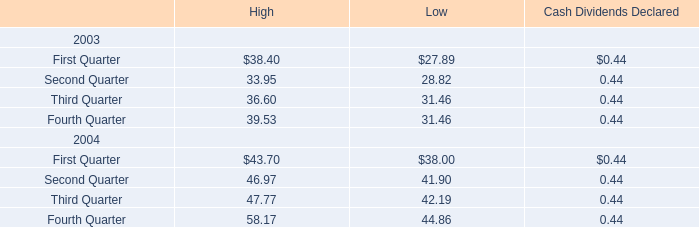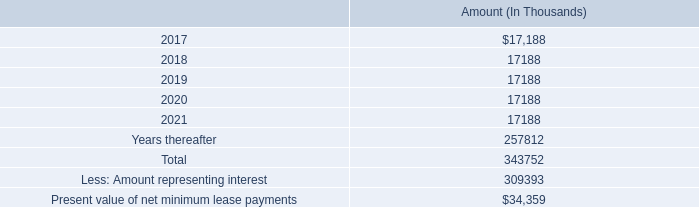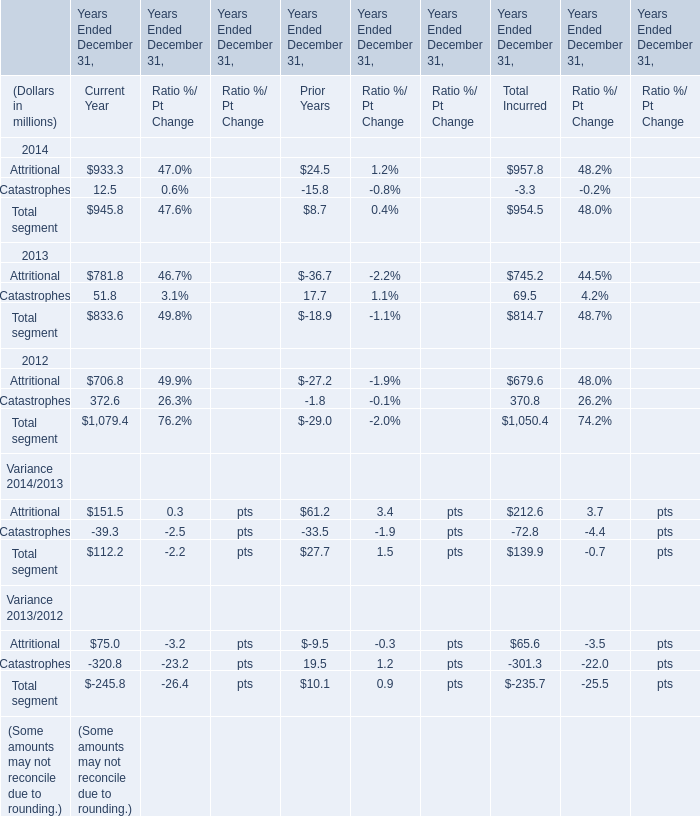In what year is Attritional for Total Incurred greater than 900? 
Answer: 2014. 